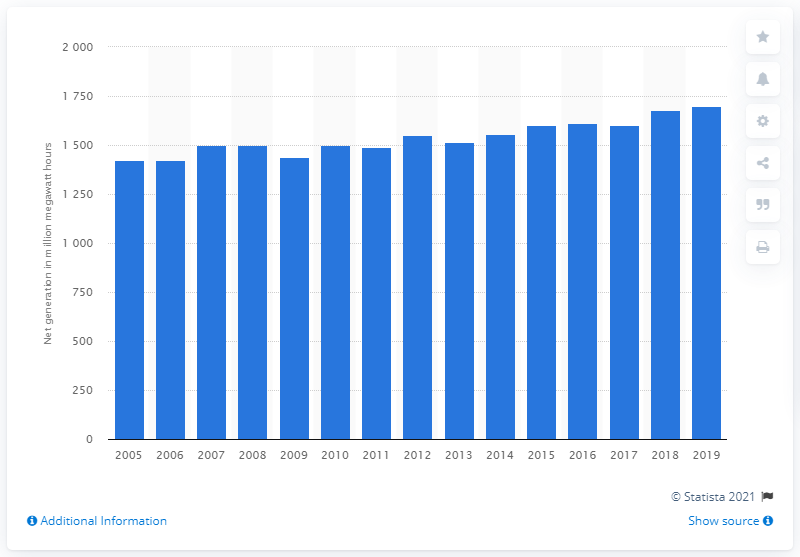Draw attention to some important aspects in this diagram. In 2019, independent power producers in the United States generated a total of 1699.63 megawatt hours of electricity. 